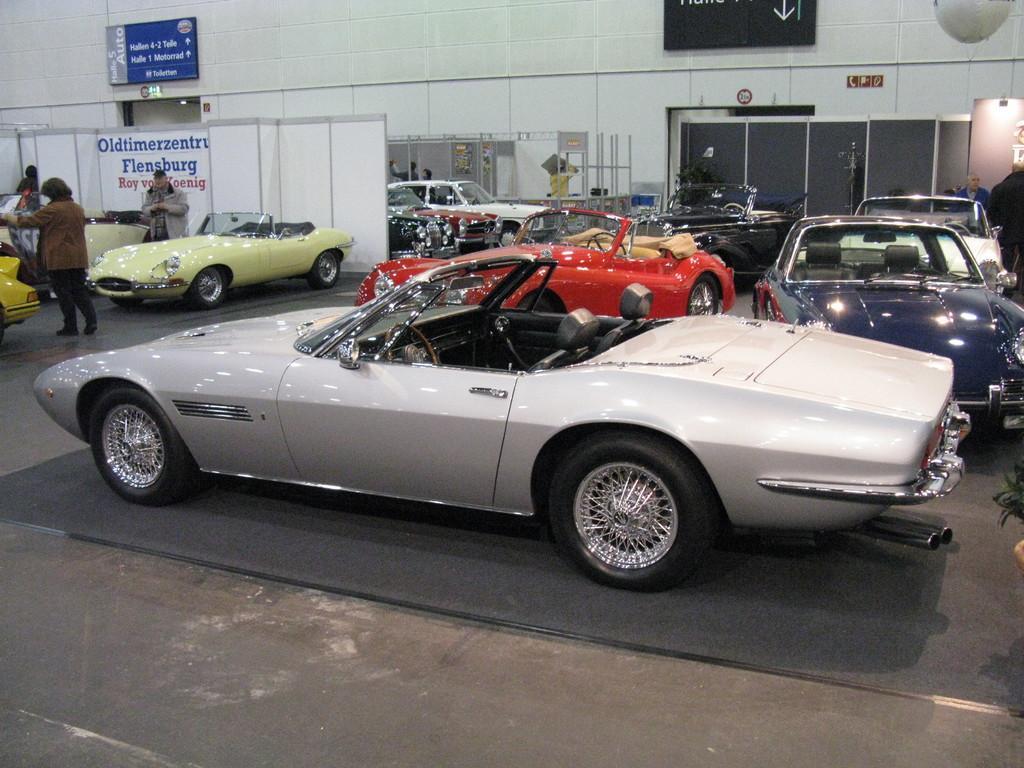Can you describe this image briefly? In this image I can see there are persons standing and there are cars on the ground. And there is a wall, to the wall there is a text written on the board. On the side there are rods. 